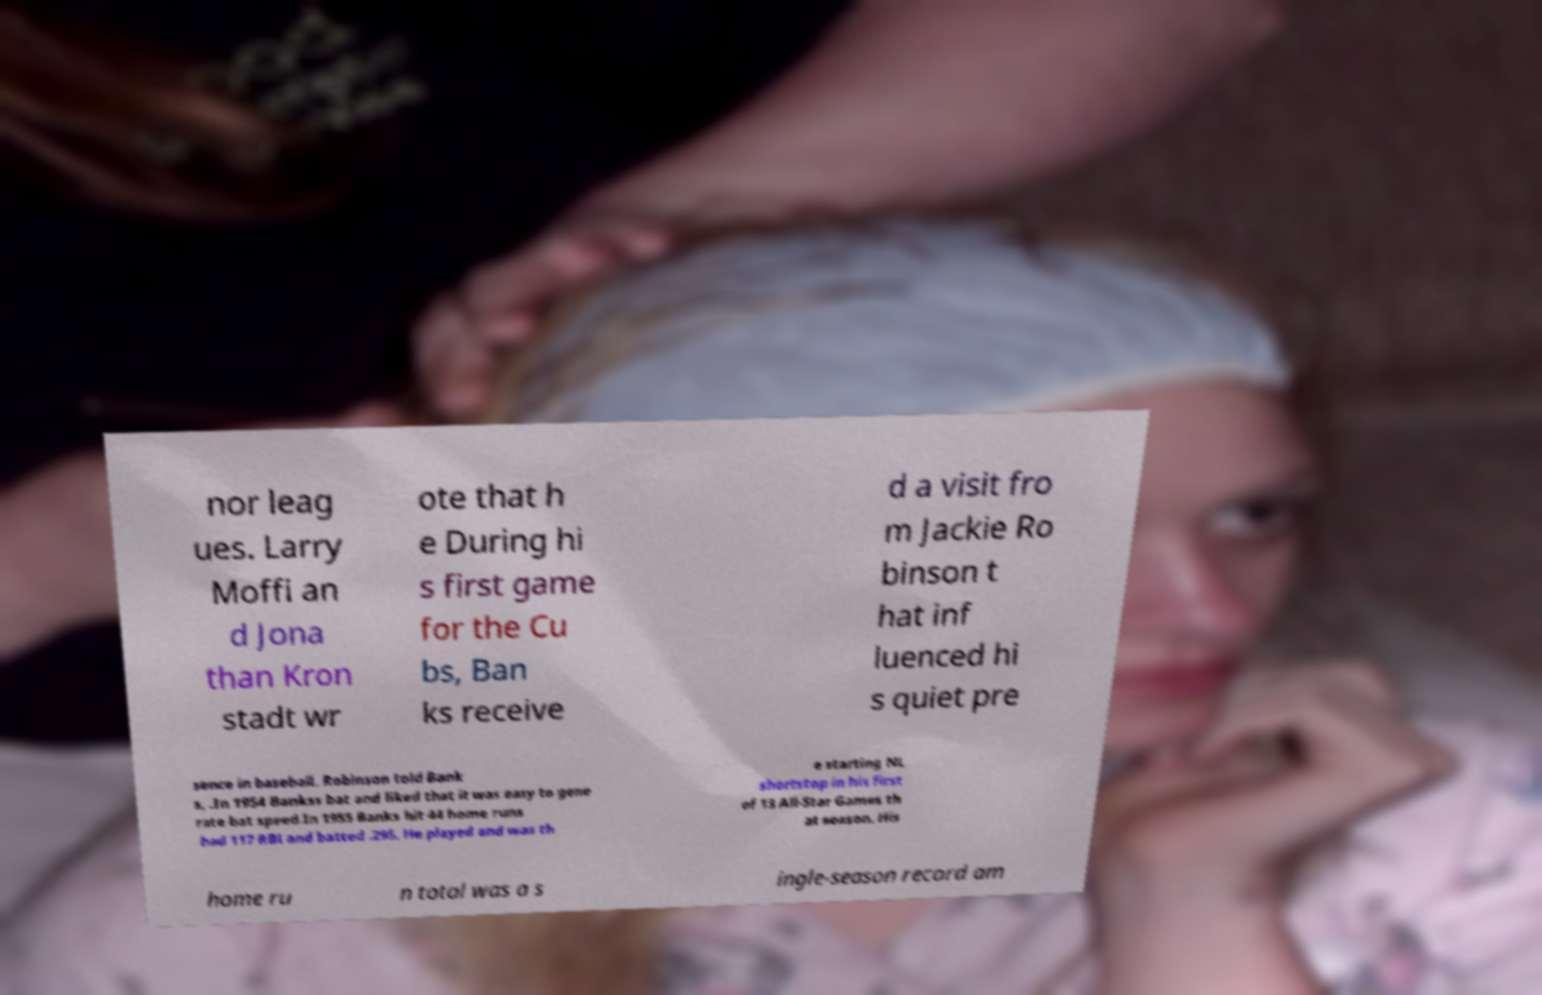Can you accurately transcribe the text from the provided image for me? nor leag ues. Larry Moffi an d Jona than Kron stadt wr ote that h e During hi s first game for the Cu bs, Ban ks receive d a visit fro m Jackie Ro binson t hat inf luenced hi s quiet pre sence in baseball. Robinson told Bank s, .In 1954 Bankss bat and liked that it was easy to gene rate bat speed.In 1955 Banks hit 44 home runs had 117 RBI and batted .295. He played and was th e starting NL shortstop in his first of 13 All-Star Games th at season. His home ru n total was a s ingle-season record am 